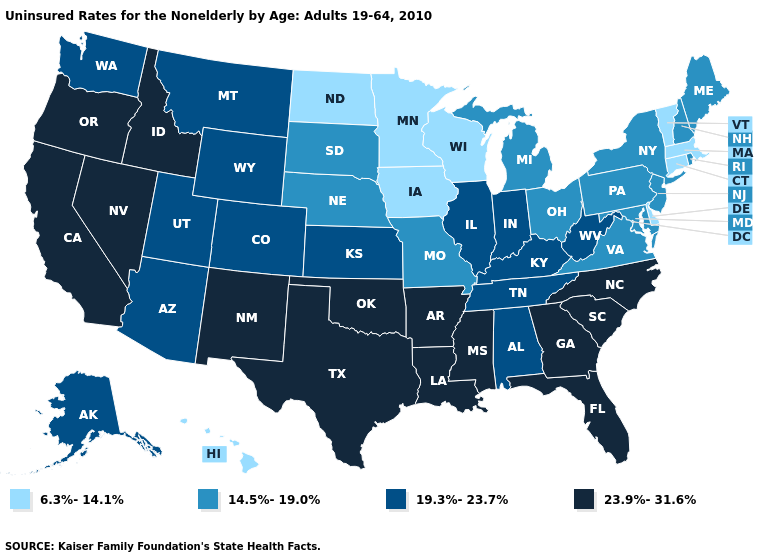Among the states that border South Dakota , which have the highest value?
Answer briefly. Montana, Wyoming. Does the first symbol in the legend represent the smallest category?
Short answer required. Yes. Name the states that have a value in the range 19.3%-23.7%?
Answer briefly. Alabama, Alaska, Arizona, Colorado, Illinois, Indiana, Kansas, Kentucky, Montana, Tennessee, Utah, Washington, West Virginia, Wyoming. How many symbols are there in the legend?
Be succinct. 4. Among the states that border Texas , which have the lowest value?
Be succinct. Arkansas, Louisiana, New Mexico, Oklahoma. What is the lowest value in states that border North Carolina?
Give a very brief answer. 14.5%-19.0%. Name the states that have a value in the range 19.3%-23.7%?
Answer briefly. Alabama, Alaska, Arizona, Colorado, Illinois, Indiana, Kansas, Kentucky, Montana, Tennessee, Utah, Washington, West Virginia, Wyoming. What is the lowest value in states that border Nebraska?
Write a very short answer. 6.3%-14.1%. What is the value of Minnesota?
Give a very brief answer. 6.3%-14.1%. What is the value of Alaska?
Be succinct. 19.3%-23.7%. Does Connecticut have the highest value in the Northeast?
Answer briefly. No. How many symbols are there in the legend?
Write a very short answer. 4. Does Oregon have the highest value in the USA?
Answer briefly. Yes. What is the lowest value in states that border Wisconsin?
Keep it brief. 6.3%-14.1%. Among the states that border California , does Arizona have the highest value?
Answer briefly. No. 